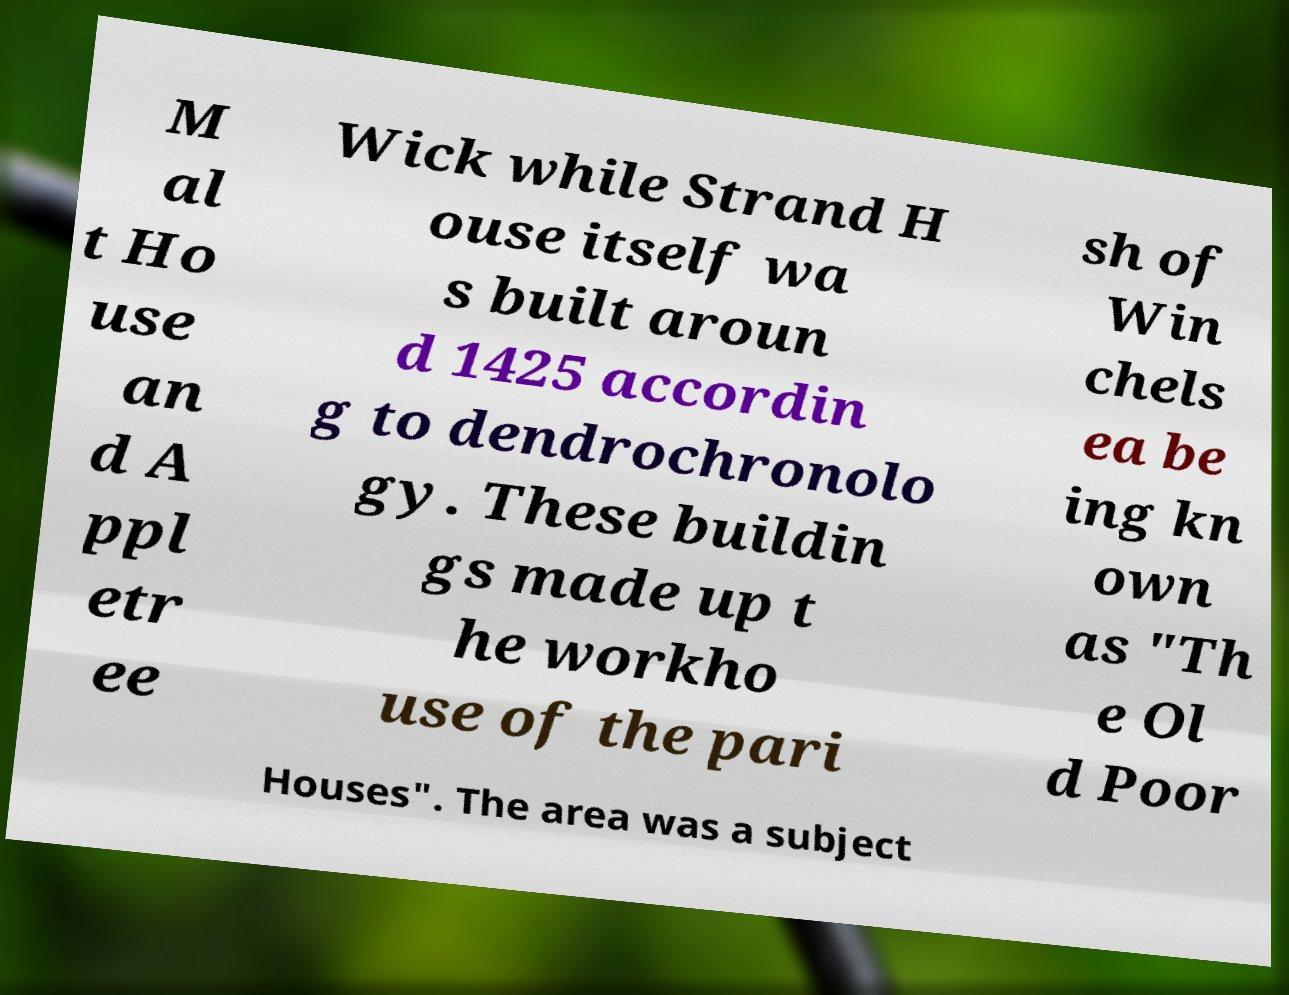Please read and relay the text visible in this image. What does it say? M al t Ho use an d A ppl etr ee Wick while Strand H ouse itself wa s built aroun d 1425 accordin g to dendrochronolo gy. These buildin gs made up t he workho use of the pari sh of Win chels ea be ing kn own as "Th e Ol d Poor Houses". The area was a subject 